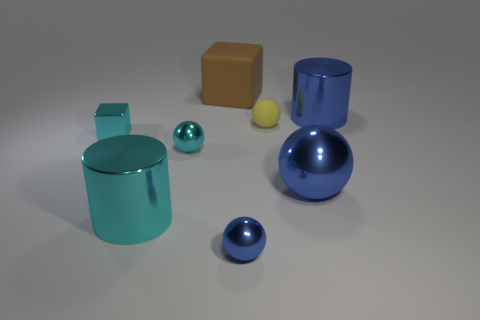There is a tiny blue thing that is the same material as the blue cylinder; what shape is it?
Ensure brevity in your answer.  Sphere. Are the big blue sphere and the cylinder in front of the cyan shiny ball made of the same material?
Give a very brief answer. Yes. There is a tiny ball that is on the left side of the brown rubber cube; are there any cyan metallic cubes that are to the right of it?
Your answer should be very brief. No. There is a tiny yellow object that is the same shape as the tiny blue metal object; what is it made of?
Offer a terse response. Rubber. What number of yellow matte things are to the right of the large cylinder that is on the right side of the yellow object?
Offer a terse response. 0. Are there any other things that are the same color as the metal cube?
Provide a short and direct response. Yes. How many objects are brown rubber things or big metallic cylinders right of the big cyan object?
Offer a terse response. 2. What is the big cylinder that is behind the cylinder on the left side of the metallic cylinder that is to the right of the big cyan thing made of?
Ensure brevity in your answer.  Metal. The cyan cylinder that is made of the same material as the small blue ball is what size?
Offer a very short reply. Large. What color is the big thing in front of the blue ball behind the tiny blue object?
Provide a short and direct response. Cyan. 